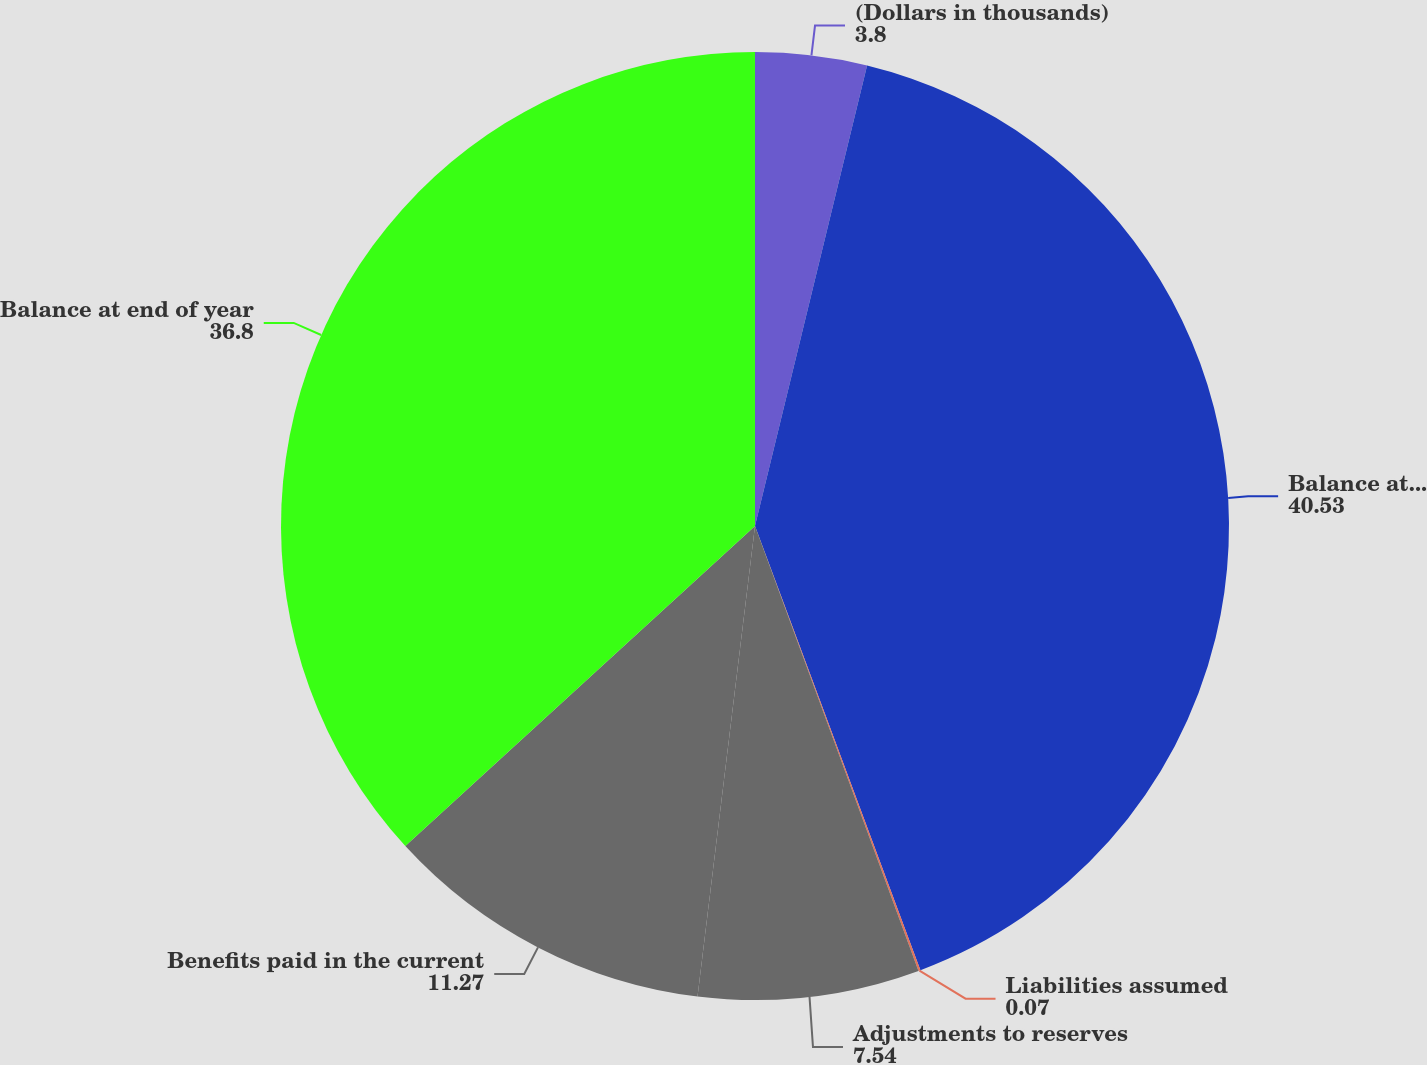<chart> <loc_0><loc_0><loc_500><loc_500><pie_chart><fcel>(Dollars in thousands)<fcel>Balance at beginning of year<fcel>Liabilities assumed<fcel>Adjustments to reserves<fcel>Benefits paid in the current<fcel>Balance at end of year<nl><fcel>3.8%<fcel>40.53%<fcel>0.07%<fcel>7.54%<fcel>11.27%<fcel>36.8%<nl></chart> 